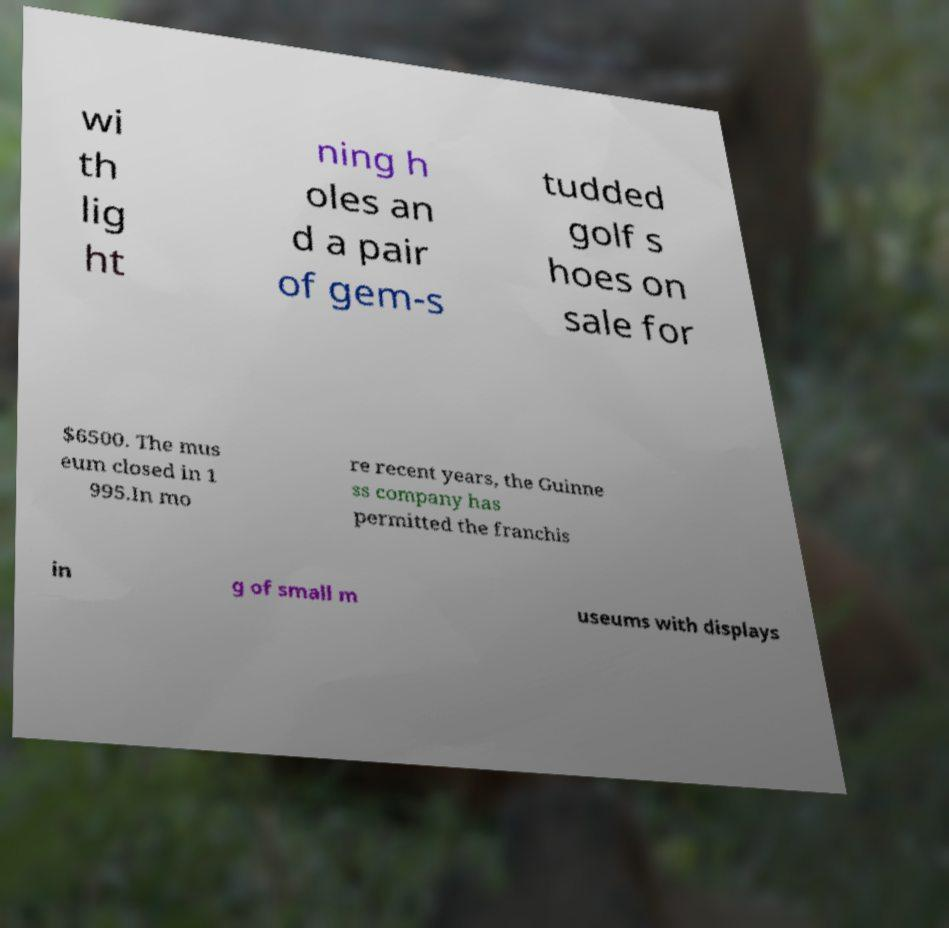Could you assist in decoding the text presented in this image and type it out clearly? wi th lig ht ning h oles an d a pair of gem-s tudded golf s hoes on sale for $6500. The mus eum closed in 1 995.In mo re recent years, the Guinne ss company has permitted the franchis in g of small m useums with displays 